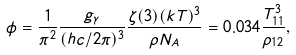<formula> <loc_0><loc_0><loc_500><loc_500>\phi = \frac { 1 } { { \pi } ^ { 2 } } \frac { g _ { \gamma } } { ( h c / 2 \pi ) ^ { 3 } } \frac { \zeta ( 3 ) ( k T ) ^ { 3 } } { \rho N _ { A } } = 0 . 0 3 4 \frac { T ^ { 3 } _ { 1 1 } } { \rho _ { 1 2 } } ,</formula> 